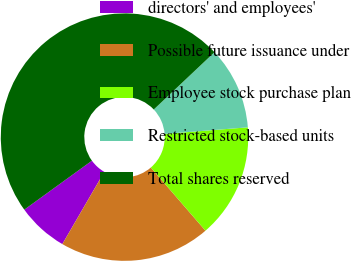Convert chart to OTSL. <chart><loc_0><loc_0><loc_500><loc_500><pie_chart><fcel>directors' and employees'<fcel>Possible future issuance under<fcel>Employee stock purchase plan<fcel>Restricted stock-based units<fcel>Total shares reserved<nl><fcel>6.65%<fcel>19.73%<fcel>14.91%<fcel>10.78%<fcel>47.94%<nl></chart> 